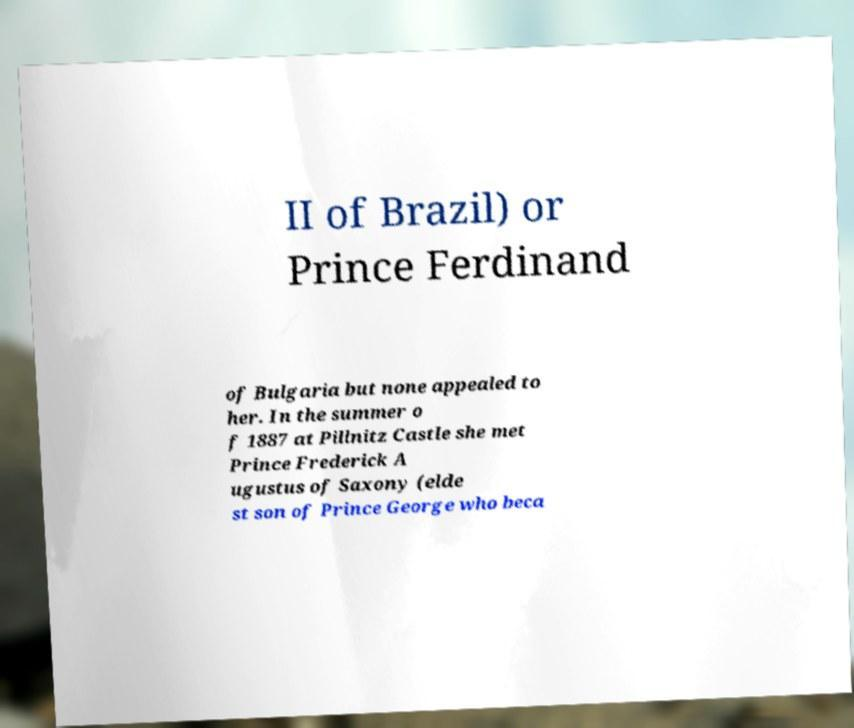Can you read and provide the text displayed in the image?This photo seems to have some interesting text. Can you extract and type it out for me? II of Brazil) or Prince Ferdinand of Bulgaria but none appealed to her. In the summer o f 1887 at Pillnitz Castle she met Prince Frederick A ugustus of Saxony (elde st son of Prince George who beca 